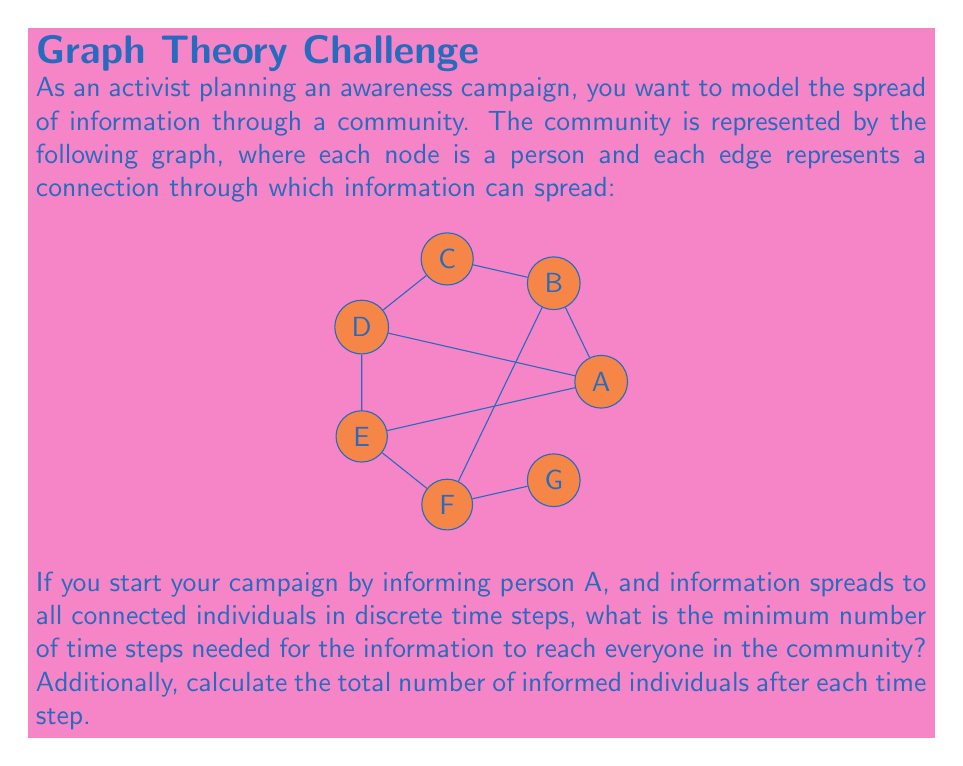Provide a solution to this math problem. Let's approach this step-by-step:

1) At time step 0, only person A is informed.

2) At time step 1, the information spreads to all individuals directly connected to A. From the graph, we can see that A is connected to B, C, D, and E.
   Informed after step 1: A, B, C, D, E
   Total informed: 5

3) At time step 2, the information spreads from the newly informed individuals to their connections:
   - B spreads to G and F
   - C, D, and E don't have any new connections to inform
   Informed after step 2: A, B, C, D, E, F, G
   Total informed: 7

4) At this point, all individuals in the community are informed, so we don't need any more time steps.

To summarize:
Time step 0: 1 informed (A)
Time step 1: 5 informed (A, B, C, D, E)
Time step 2: 7 informed (A, B, C, D, E, F, G)

The minimum number of time steps needed is 2.

We can represent this mathematically as:

Let $I(t)$ be the number of informed individuals at time step $t$.

$I(0) = 1$
$I(1) = 5$
$I(2) = 7$

The sequence terminates at $t=2$ because $I(2)$ equals the total number of nodes in the graph.
Answer: 2 time steps; $I(t) = \{1, 5, 7\}$ for $t = 0, 1, 2$ 